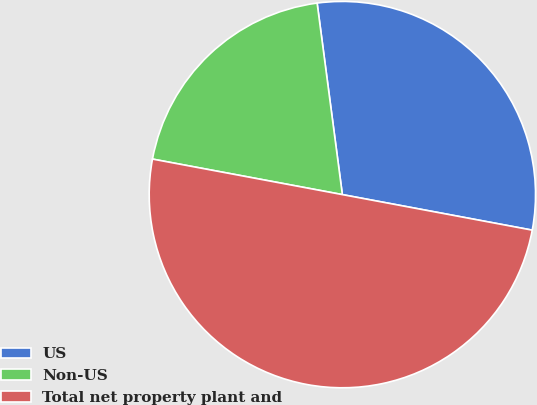Convert chart to OTSL. <chart><loc_0><loc_0><loc_500><loc_500><pie_chart><fcel>US<fcel>Non-US<fcel>Total net property plant and<nl><fcel>30.03%<fcel>19.97%<fcel>50.0%<nl></chart> 